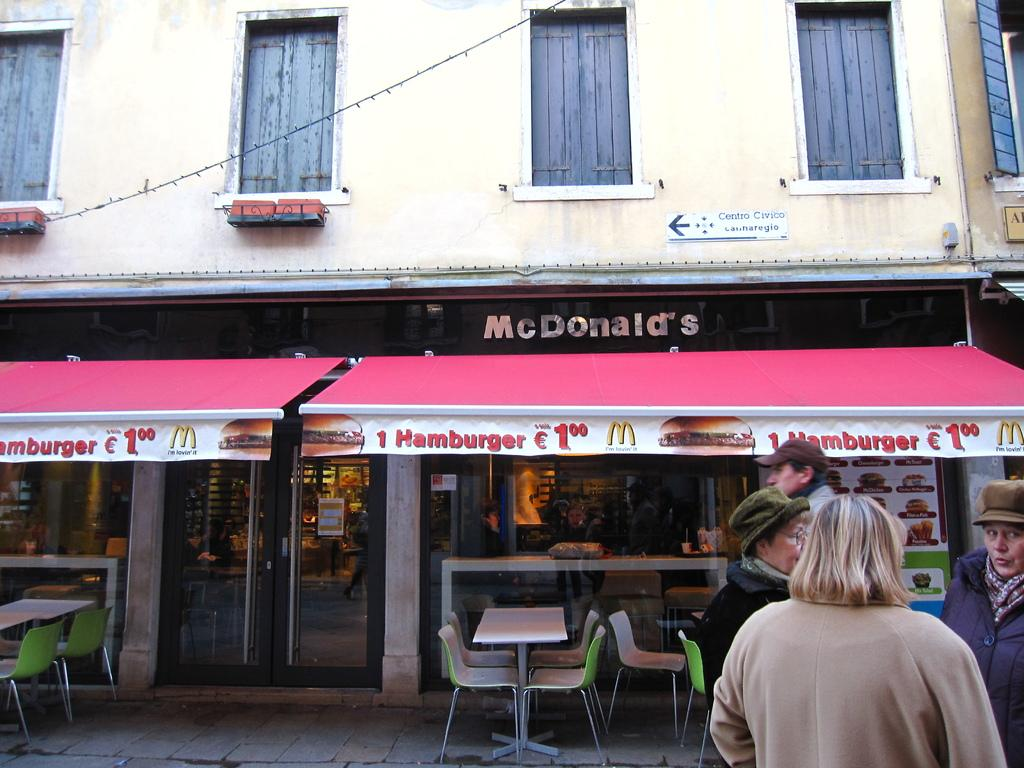Who or what can be seen in the image? There are people in the image. What type of furniture is present in the image? There are chairs and tables in the image. What can be seen in the distance in the image? There is a building in the background of the image. What month is it in the image? The month cannot be determined from the image, as there is no information about the time of year. What activity are the people engaged in within the image? The activity cannot be determined from the image, as there is no information about what the people are doing. 